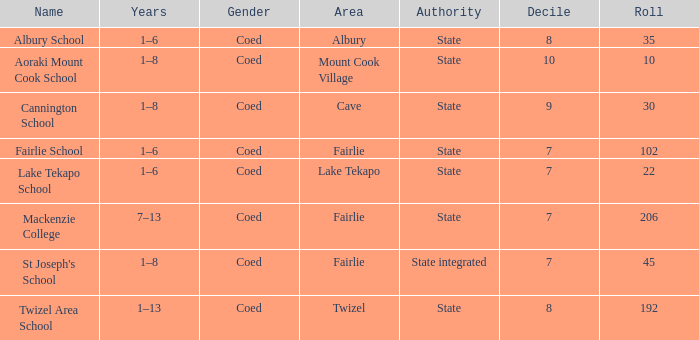What is the total Decile that has a state authority, fairlie area and roll smarter than 206? 1.0. 